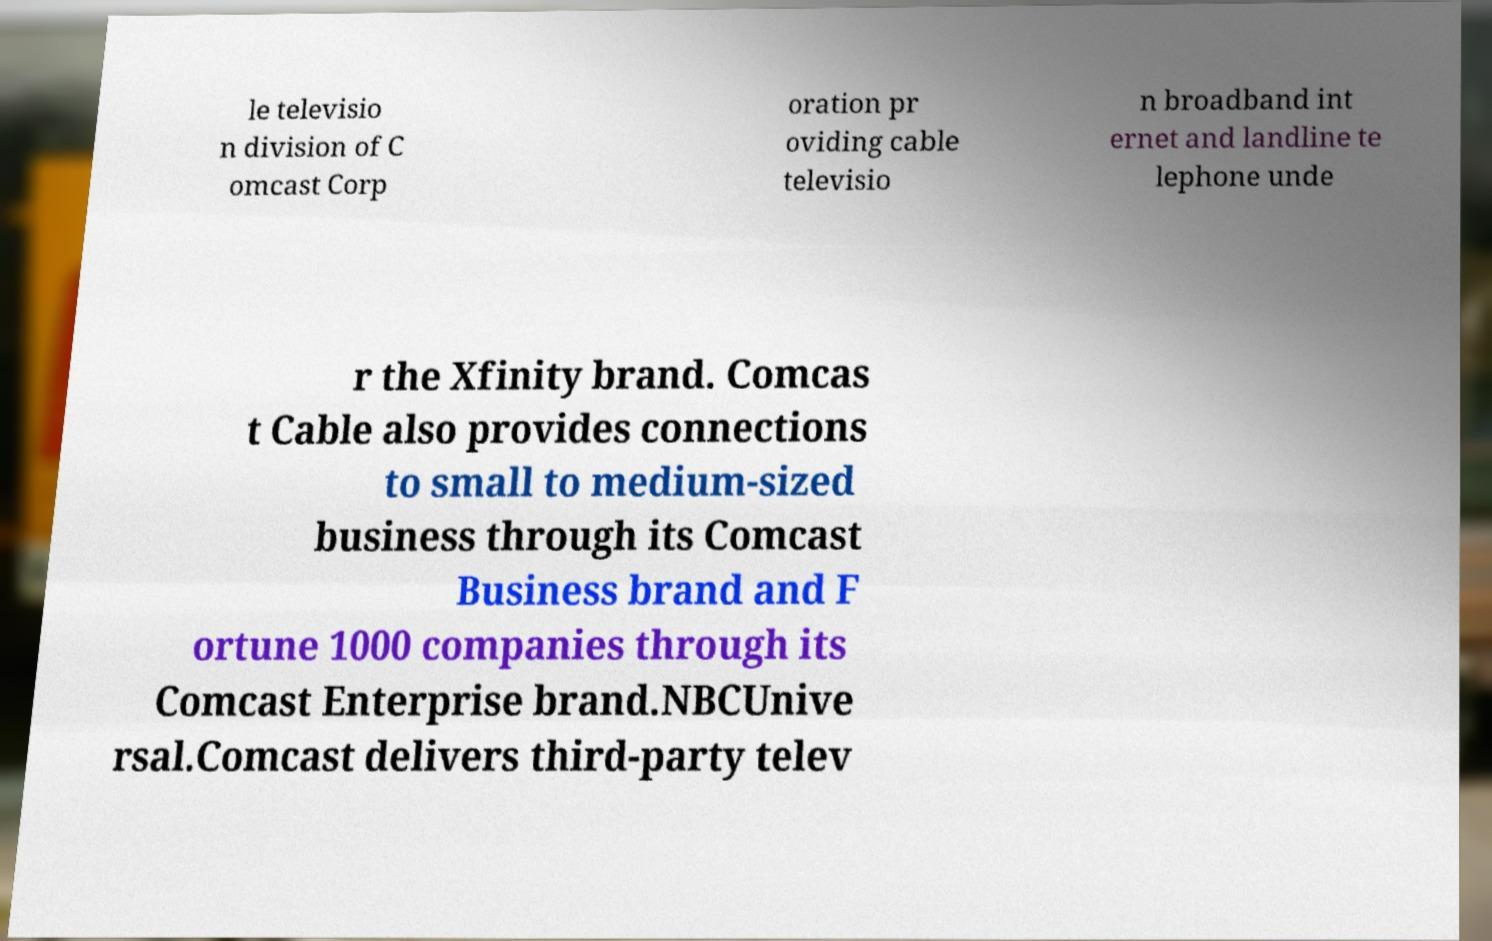For documentation purposes, I need the text within this image transcribed. Could you provide that? le televisio n division of C omcast Corp oration pr oviding cable televisio n broadband int ernet and landline te lephone unde r the Xfinity brand. Comcas t Cable also provides connections to small to medium-sized business through its Comcast Business brand and F ortune 1000 companies through its Comcast Enterprise brand.NBCUnive rsal.Comcast delivers third-party telev 